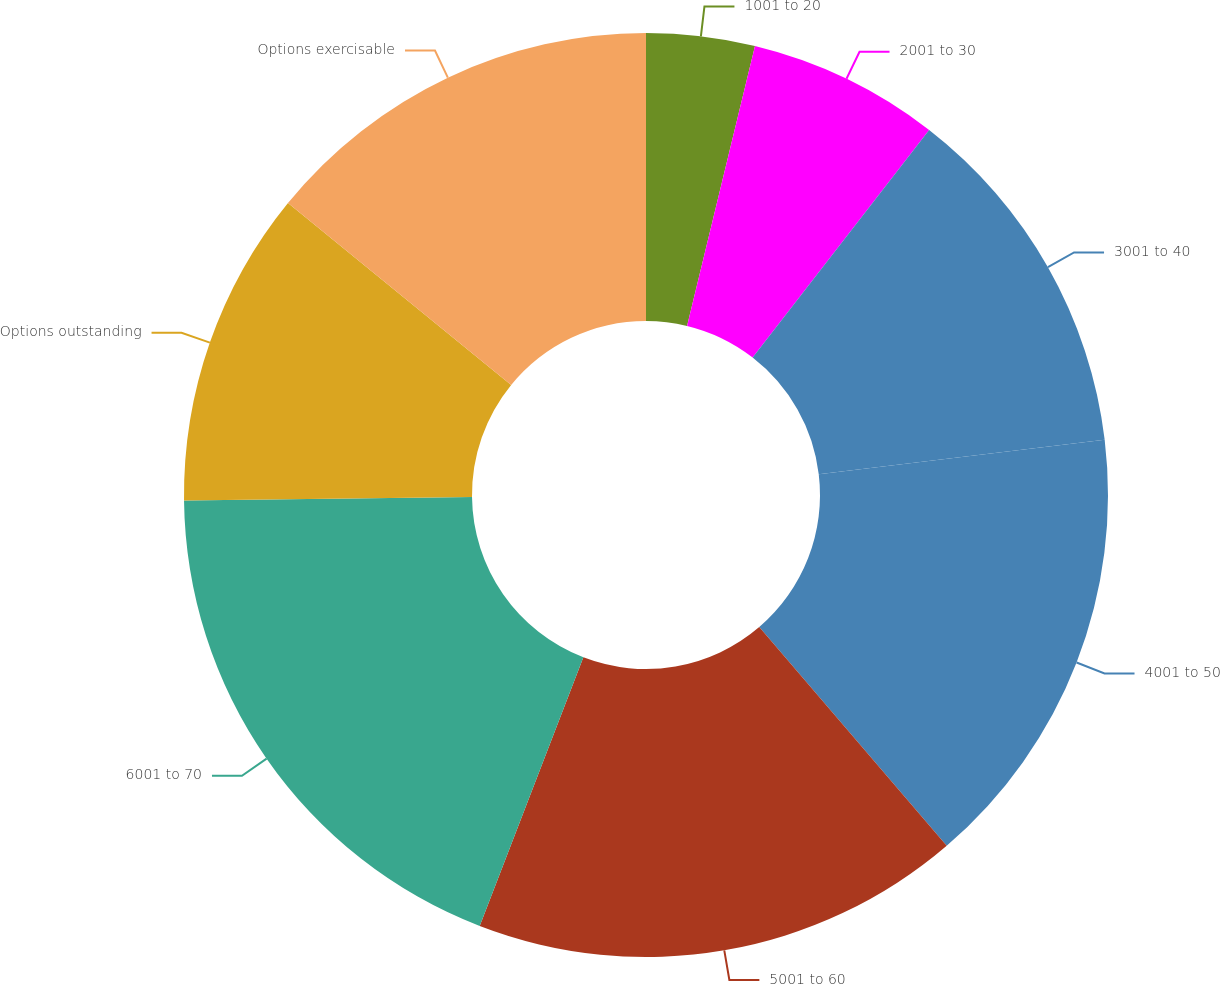<chart> <loc_0><loc_0><loc_500><loc_500><pie_chart><fcel>1001 to 20<fcel>2001 to 30<fcel>3001 to 40<fcel>4001 to 50<fcel>5001 to 60<fcel>6001 to 70<fcel>Options outstanding<fcel>Options exercisable<nl><fcel>3.79%<fcel>6.71%<fcel>12.59%<fcel>15.63%<fcel>17.14%<fcel>18.95%<fcel>11.08%<fcel>14.11%<nl></chart> 